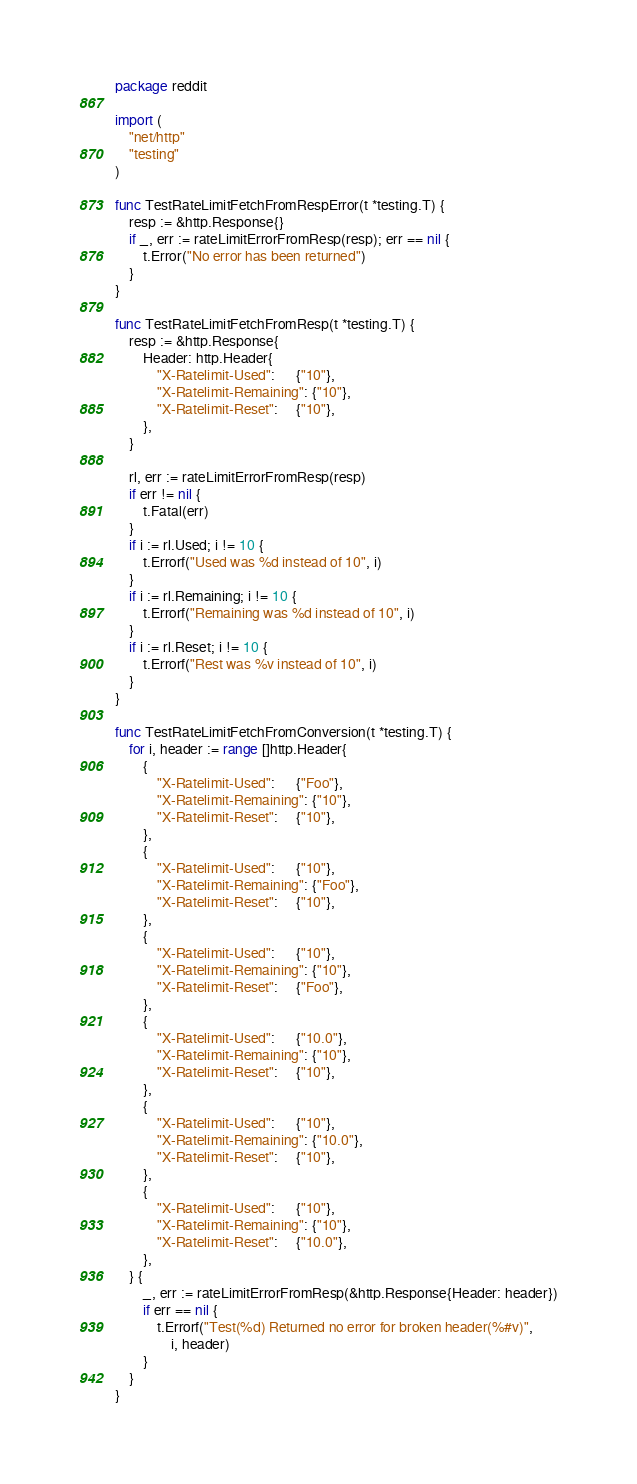<code> <loc_0><loc_0><loc_500><loc_500><_Go_>package reddit

import (
	"net/http"
	"testing"
)

func TestRateLimitFetchFromRespError(t *testing.T) {
	resp := &http.Response{}
	if _, err := rateLimitErrorFromResp(resp); err == nil {
		t.Error("No error has been returned")
	}
}

func TestRateLimitFetchFromResp(t *testing.T) {
	resp := &http.Response{
		Header: http.Header{
			"X-Ratelimit-Used":      {"10"},
			"X-Ratelimit-Remaining": {"10"},
			"X-Ratelimit-Reset":     {"10"},
		},
	}

	rl, err := rateLimitErrorFromResp(resp)
	if err != nil {
		t.Fatal(err)
	}
	if i := rl.Used; i != 10 {
		t.Errorf("Used was %d instead of 10", i)
	}
	if i := rl.Remaining; i != 10 {
		t.Errorf("Remaining was %d instead of 10", i)
	}
	if i := rl.Reset; i != 10 {
		t.Errorf("Rest was %v instead of 10", i)
	}
}

func TestRateLimitFetchFromConversion(t *testing.T) {
	for i, header := range []http.Header{
		{
			"X-Ratelimit-Used":      {"Foo"},
			"X-Ratelimit-Remaining": {"10"},
			"X-Ratelimit-Reset":     {"10"},
		},
		{
			"X-Ratelimit-Used":      {"10"},
			"X-Ratelimit-Remaining": {"Foo"},
			"X-Ratelimit-Reset":     {"10"},
		},
		{
			"X-Ratelimit-Used":      {"10"},
			"X-Ratelimit-Remaining": {"10"},
			"X-Ratelimit-Reset":     {"Foo"},
		},
		{
			"X-Ratelimit-Used":      {"10.0"},
			"X-Ratelimit-Remaining": {"10"},
			"X-Ratelimit-Reset":     {"10"},
		},
		{
			"X-Ratelimit-Used":      {"10"},
			"X-Ratelimit-Remaining": {"10.0"},
			"X-Ratelimit-Reset":     {"10"},
		},
		{
			"X-Ratelimit-Used":      {"10"},
			"X-Ratelimit-Remaining": {"10"},
			"X-Ratelimit-Reset":     {"10.0"},
		},
	} {
		_, err := rateLimitErrorFromResp(&http.Response{Header: header})
		if err == nil {
			t.Errorf("Test(%d) Returned no error for broken header(%#v)",
				i, header)
		}
	}
}
</code> 